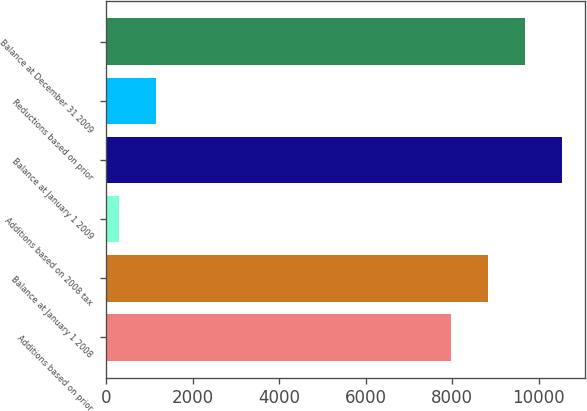Convert chart to OTSL. <chart><loc_0><loc_0><loc_500><loc_500><bar_chart><fcel>Additions based on prior<fcel>Balance at January 1 2008<fcel>Additions based on 2008 tax<fcel>Balance at January 1 2009<fcel>Reductions based on prior<fcel>Balance at December 31 2009<nl><fcel>7975<fcel>8831.2<fcel>294<fcel>10543.6<fcel>1150.2<fcel>9687.4<nl></chart> 